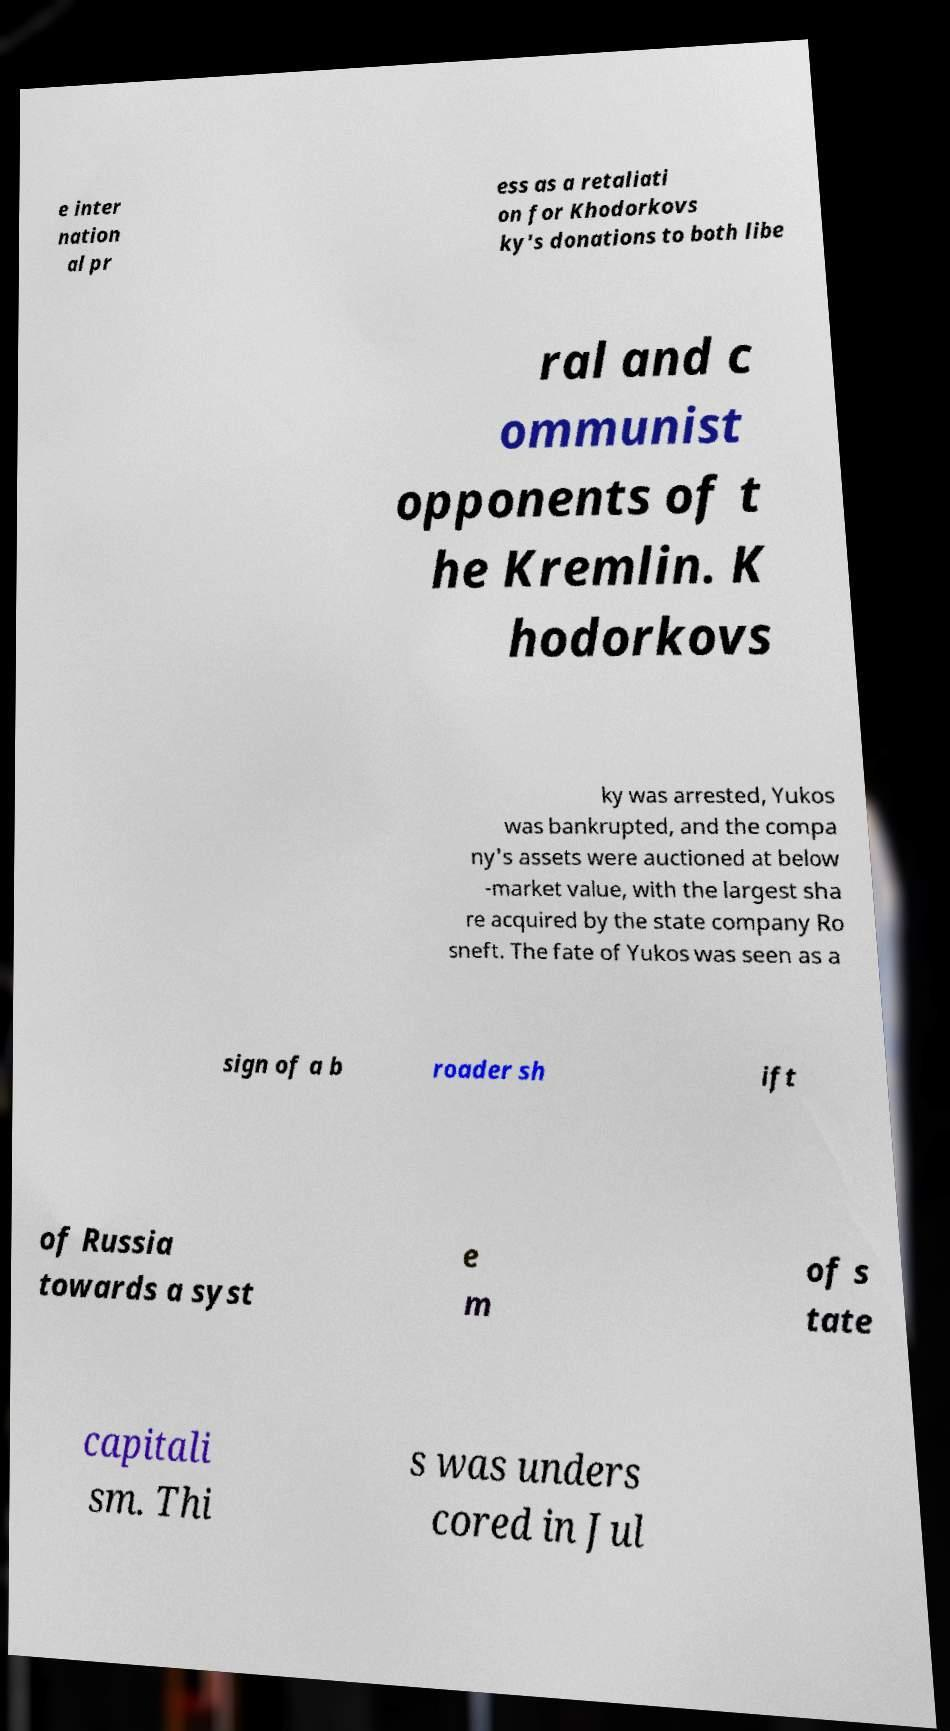Could you assist in decoding the text presented in this image and type it out clearly? e inter nation al pr ess as a retaliati on for Khodorkovs ky's donations to both libe ral and c ommunist opponents of t he Kremlin. K hodorkovs ky was arrested, Yukos was bankrupted, and the compa ny's assets were auctioned at below -market value, with the largest sha re acquired by the state company Ro sneft. The fate of Yukos was seen as a sign of a b roader sh ift of Russia towards a syst e m of s tate capitali sm. Thi s was unders cored in Jul 